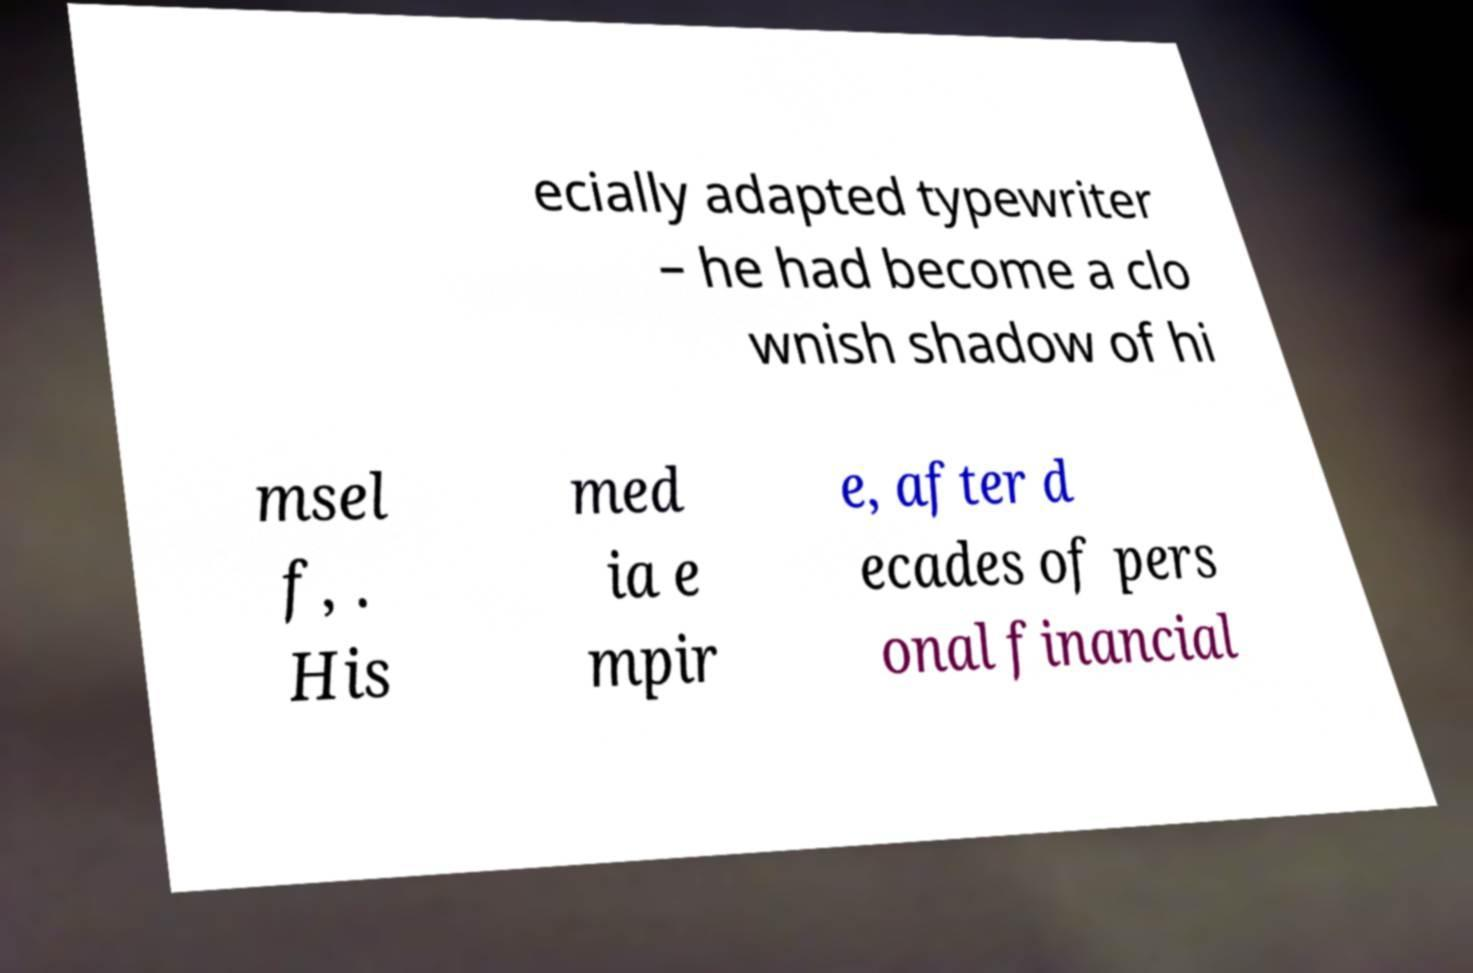What messages or text are displayed in this image? I need them in a readable, typed format. ecially adapted typewriter – he had become a clo wnish shadow of hi msel f, . His med ia e mpir e, after d ecades of pers onal financial 